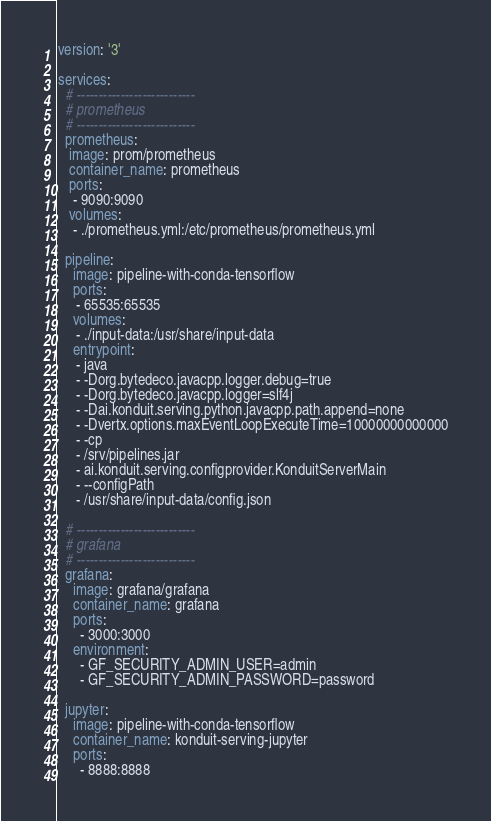Convert code to text. <code><loc_0><loc_0><loc_500><loc_500><_YAML_>version: '3'

services:
  # ---------------------------
  # prometheus
  # ---------------------------
  prometheus:
   image: prom/prometheus
   container_name: prometheus
   ports:
    - 9090:9090
   volumes:
    - ./prometheus.yml:/etc/prometheus/prometheus.yml

  pipeline:
    image: pipeline-with-conda-tensorflow
    ports:
     - 65535:65535
    volumes:
     - ./input-data:/usr/share/input-data
    entrypoint:
     - java
     - -Dorg.bytedeco.javacpp.logger.debug=true
     - -Dorg.bytedeco.javacpp.logger=slf4j
     - -Dai.konduit.serving.python.javacpp.path.append=none
     - -Dvertx.options.maxEventLoopExecuteTime=10000000000000
     - -cp
     - /srv/pipelines.jar
     - ai.konduit.serving.configprovider.KonduitServerMain
     - --configPath
     - /usr/share/input-data/config.json

  # ---------------------------
  # grafana
  # ---------------------------
  grafana:
    image: grafana/grafana
    container_name: grafana
    ports:
      - 3000:3000
    environment:
      - GF_SECURITY_ADMIN_USER=admin
      - GF_SECURITY_ADMIN_PASSWORD=password

  jupyter:
    image: pipeline-with-conda-tensorflow
    container_name: konduit-serving-jupyter
    ports:
      - 8888:8888

</code> 